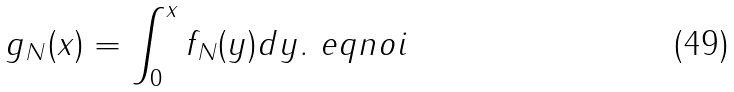Convert formula to latex. <formula><loc_0><loc_0><loc_500><loc_500>g _ { N } ( x ) = \int _ { 0 } ^ { x } f _ { N } ( y ) d y . \ e q n o i</formula> 